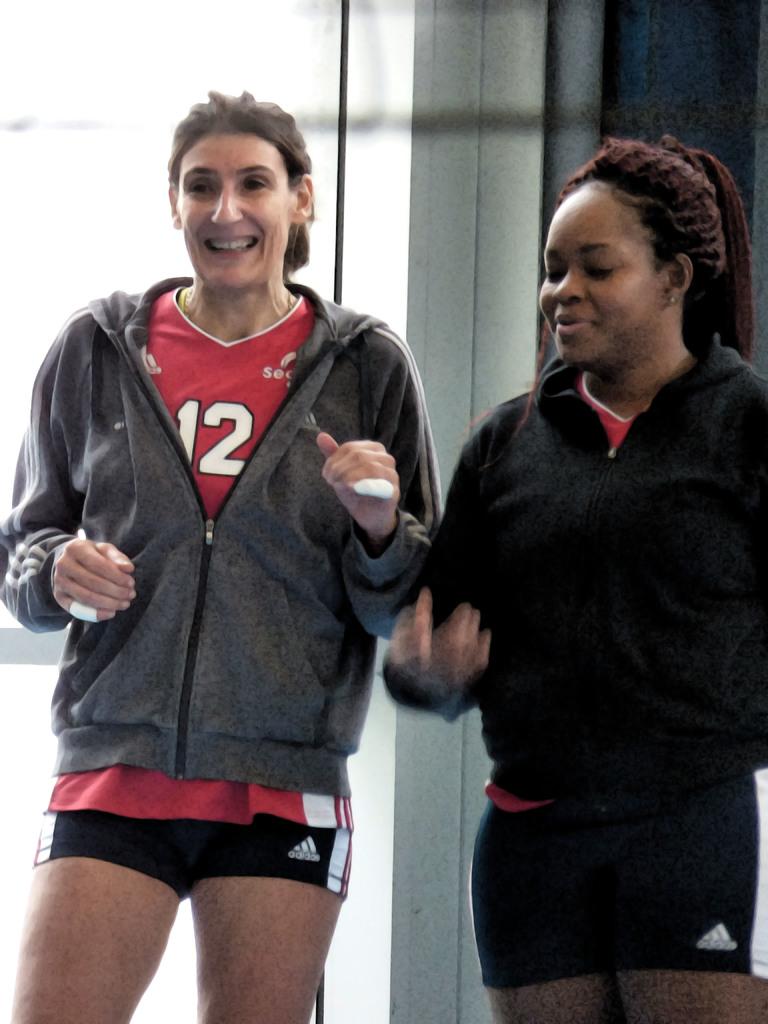The shorts they're wearing are from where?
Ensure brevity in your answer.  Adidas. 